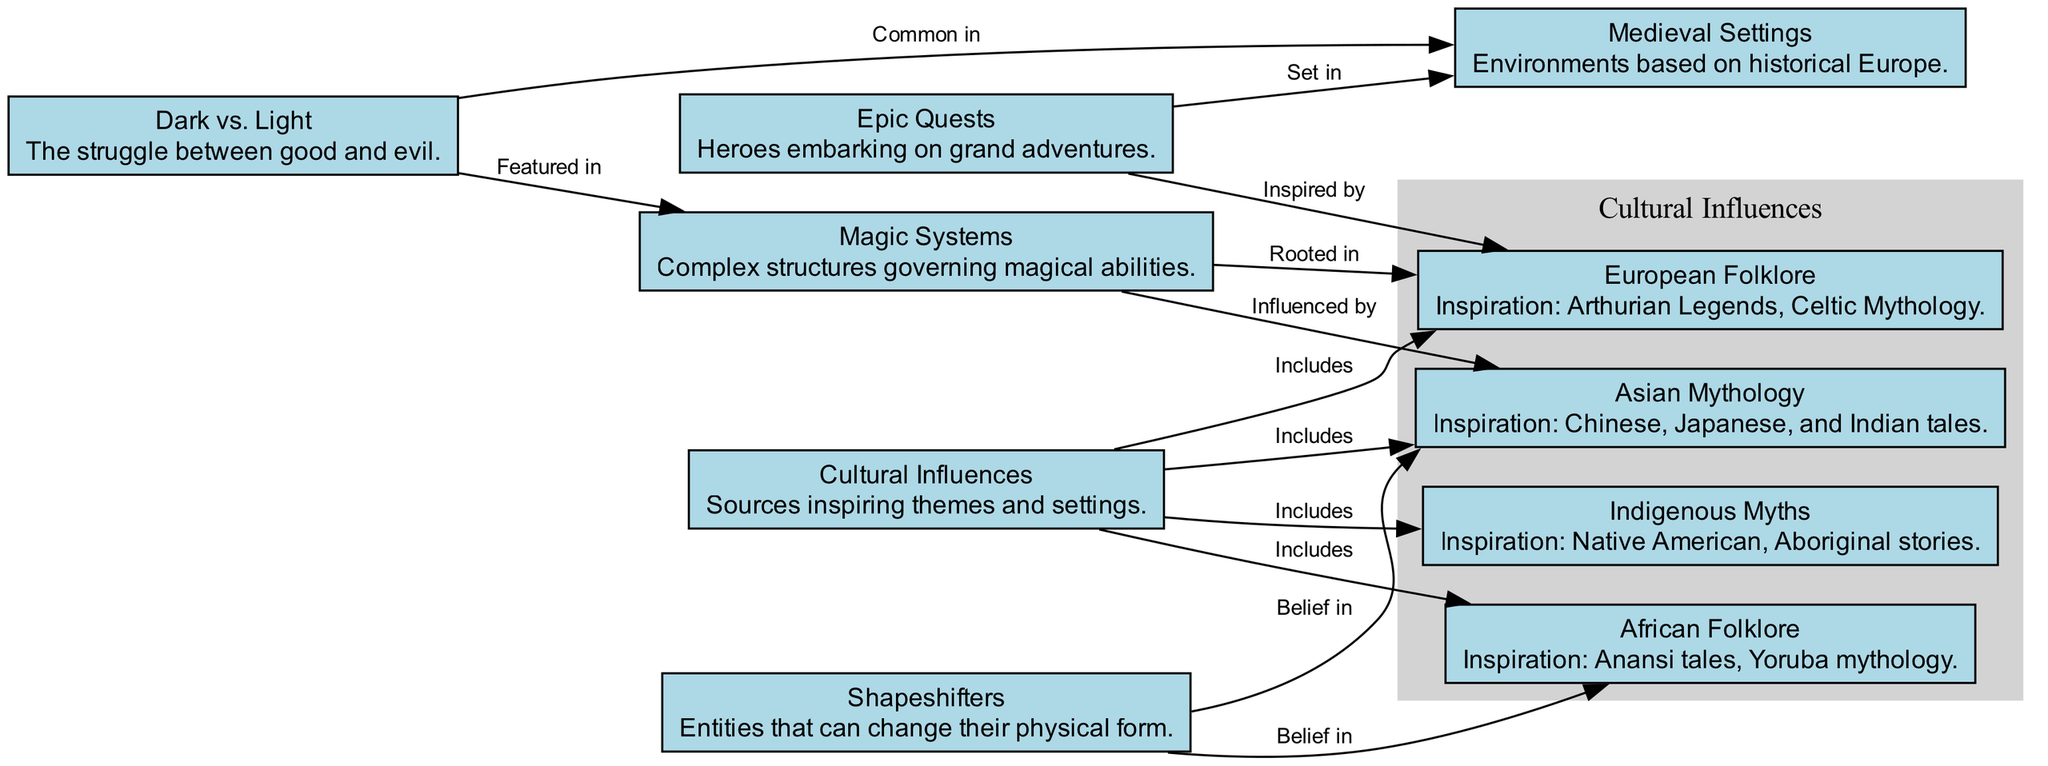What are the main categories of cultural influences according to the diagram? There are five categories of cultural influences shown in the diagram. They are European Folklore, Asian Mythology, Indigenous Myths, African Folklore, and the overarching category Cultural Influences that includes these sources.
Answer: European Folklore, Asian Mythology, Indigenous Myths, African Folklore How many nodes are there in the diagram? By counting the nodes listed, there are a total of ten nodes depicted in the diagram. Each node represents a distinct theme or cultural influence.
Answer: 10 What type of setting is associated with epic quests? The epic quests are commonly set in medieval settings, as indicated by the directed edge between the nodes. This suggests that many hero adventures are situated in environments based on historical Europe.
Answer: Medieval Settings Which cultural influence includes Native American stories? The node labeled Indigenous Myths includes Native American stories, showcasing the cultural richness and narrative traditions of indigenous peoples. This is visually represented in the diagram under Cultural Influences.
Answer: Indigenous Myths What is a common theme featured in both magic systems and the dark vs. light trope? Both magic systems and the dark vs. light theme feature the struggle between good and evil, which is evident from the direct connections depicted between these two nodes.
Answer: The struggle between good and evil 